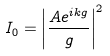<formula> <loc_0><loc_0><loc_500><loc_500>I _ { 0 } = \left | { \frac { A e ^ { i k g } } { g } } \right | ^ { 2 }</formula> 